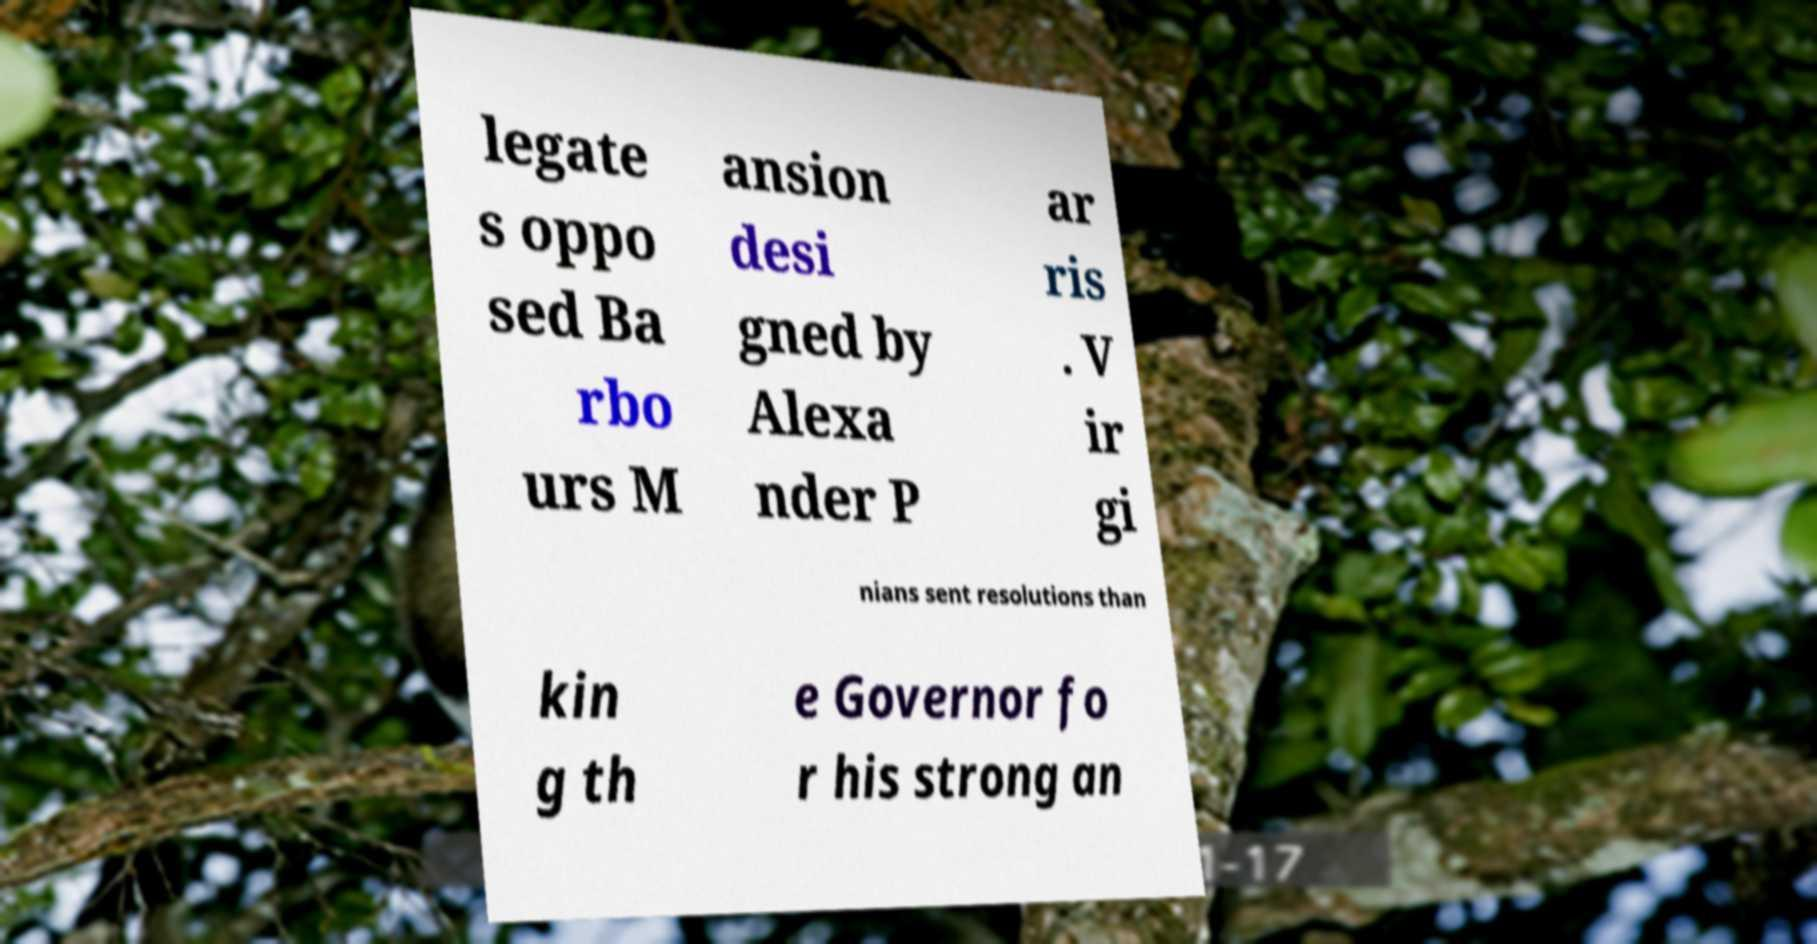Could you assist in decoding the text presented in this image and type it out clearly? legate s oppo sed Ba rbo urs M ansion desi gned by Alexa nder P ar ris . V ir gi nians sent resolutions than kin g th e Governor fo r his strong an 